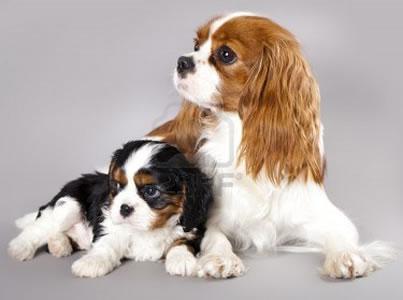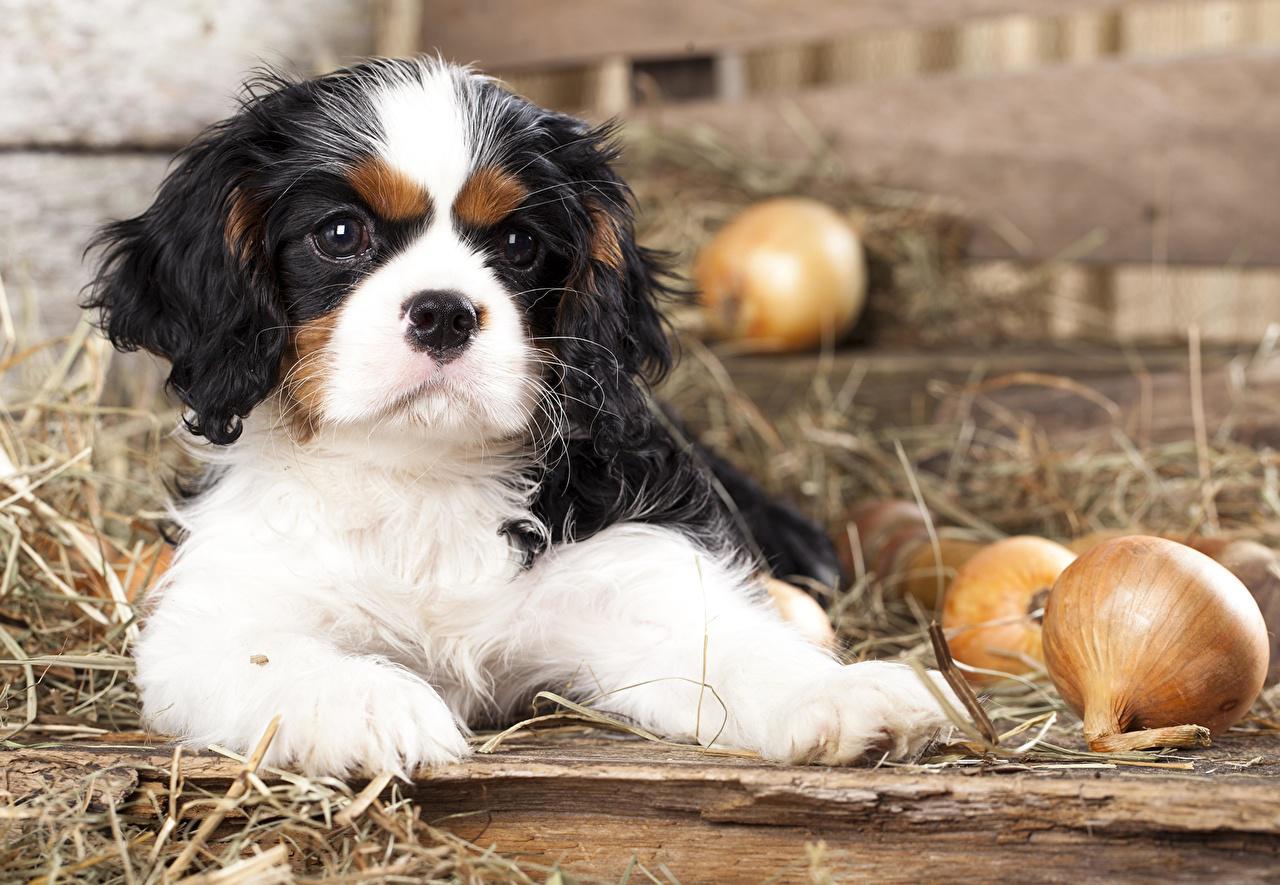The first image is the image on the left, the second image is the image on the right. Considering the images on both sides, is "At least one image shows one or more Cavalier King Charles Spaniels sitting upright." valid? Answer yes or no. No. 